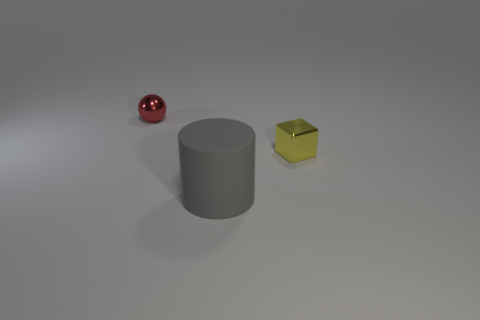Is the number of gray matte objects behind the small yellow metal thing less than the number of red spheres behind the red ball?
Make the answer very short. No. There is a metal block; is it the same size as the metallic object behind the small metal block?
Provide a short and direct response. Yes. The object that is in front of the small metal ball and behind the big gray cylinder has what shape?
Your response must be concise. Cube. The red sphere that is the same material as the small block is what size?
Make the answer very short. Small. There is a tiny metal thing to the right of the small sphere; what number of large matte cylinders are right of it?
Your answer should be very brief. 0. Is the small object that is right of the small red metallic object made of the same material as the big object?
Offer a very short reply. No. Is there anything else that has the same material as the tiny red object?
Keep it short and to the point. Yes. How big is the metal object right of the tiny metallic object that is left of the metal block?
Provide a short and direct response. Small. There is a thing that is in front of the small object in front of the tiny metallic object that is behind the small block; what is its size?
Make the answer very short. Large. Does the thing behind the yellow thing have the same shape as the thing in front of the small cube?
Your response must be concise. No. 